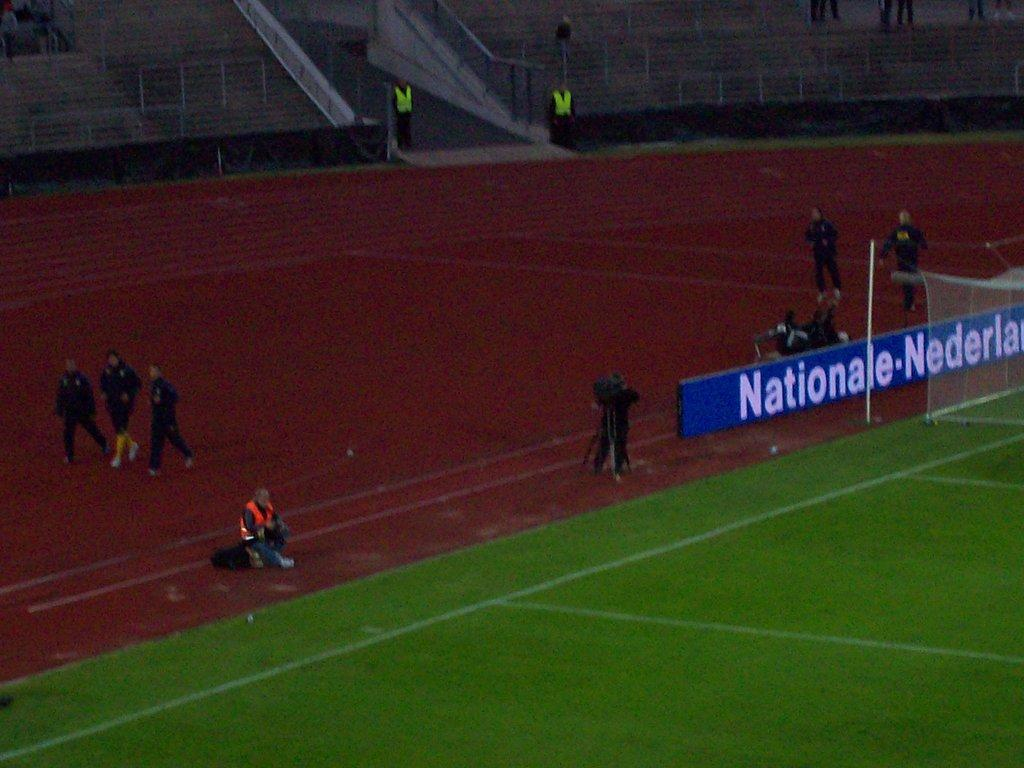Provide a one-sentence caption for the provided image. People are walking around a track while some sit behind the Nationale banner. 